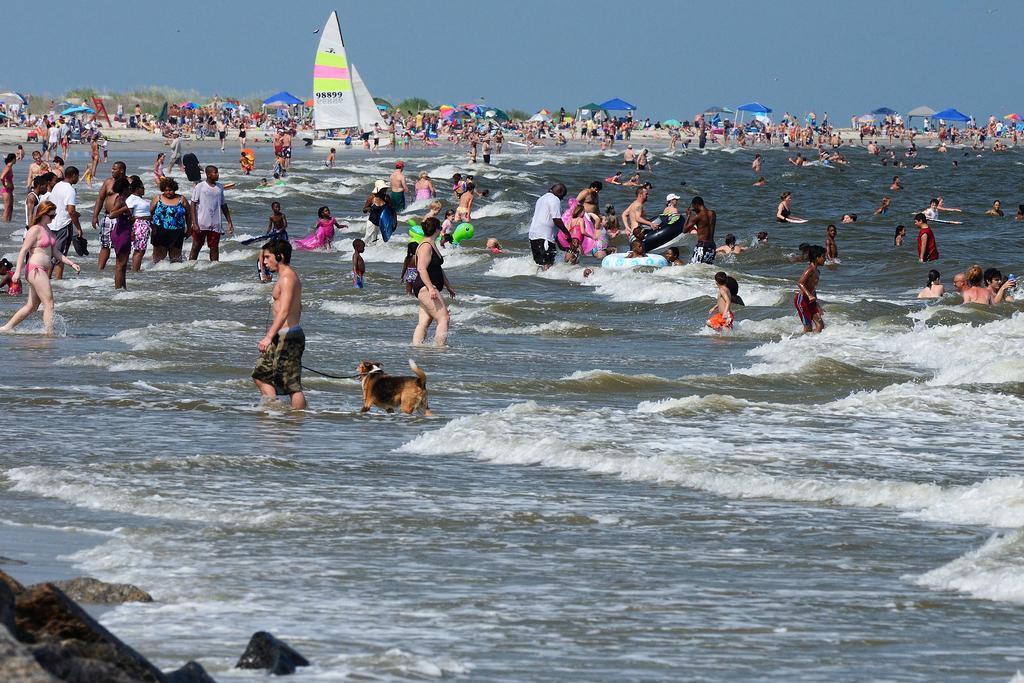How would you summarize this image in a sentence or two? In this image there are boats on the water , dog and group of people standing in water , there are inflatable swim rings in water , pipes with umbrellas, trees,sky. 